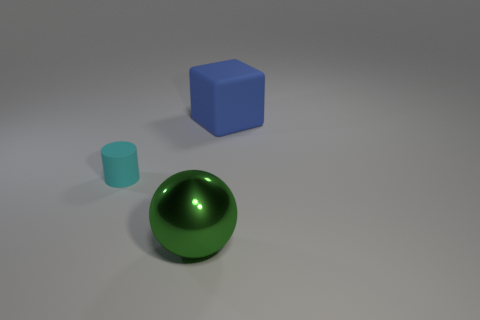Add 2 big blue rubber things. How many objects exist? 5 Subtract all cylinders. How many objects are left? 2 Subtract all small blocks. Subtract all large metallic balls. How many objects are left? 2 Add 1 big blue objects. How many big blue objects are left? 2 Add 3 large blue things. How many large blue things exist? 4 Subtract 0 yellow cylinders. How many objects are left? 3 